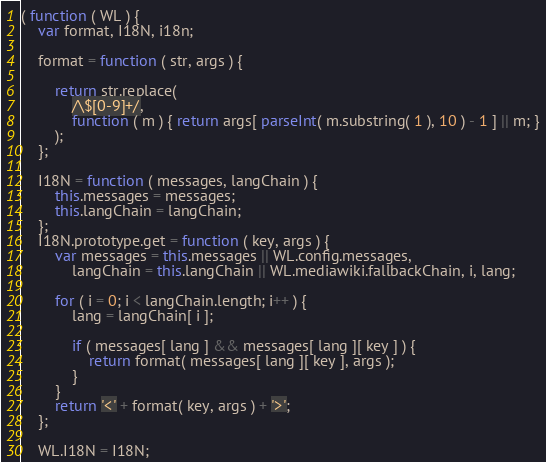<code> <loc_0><loc_0><loc_500><loc_500><_JavaScript_>( function ( WL ) {
	var format, I18N, i18n;

	format = function ( str, args ) {

		return str.replace(
			/\$[0-9]+/,
			function ( m ) { return args[ parseInt( m.substring( 1 ), 10 ) - 1 ] || m; }
		);
	};

	I18N = function ( messages, langChain ) {
		this.messages = messages;
		this.langChain = langChain;
	};
	I18N.prototype.get = function ( key, args ) {
		var messages = this.messages || WL.config.messages,
			langChain = this.langChain || WL.mediawiki.fallbackChain, i, lang;

		for ( i = 0; i < langChain.length; i++ ) {
			lang = langChain[ i ];

			if ( messages[ lang ] && messages[ lang ][ key ] ) {
				return format( messages[ lang ][ key ], args );
			}
		}
		return '<' + format( key, args ) + '>';
	};

	WL.I18N = I18N;</code> 